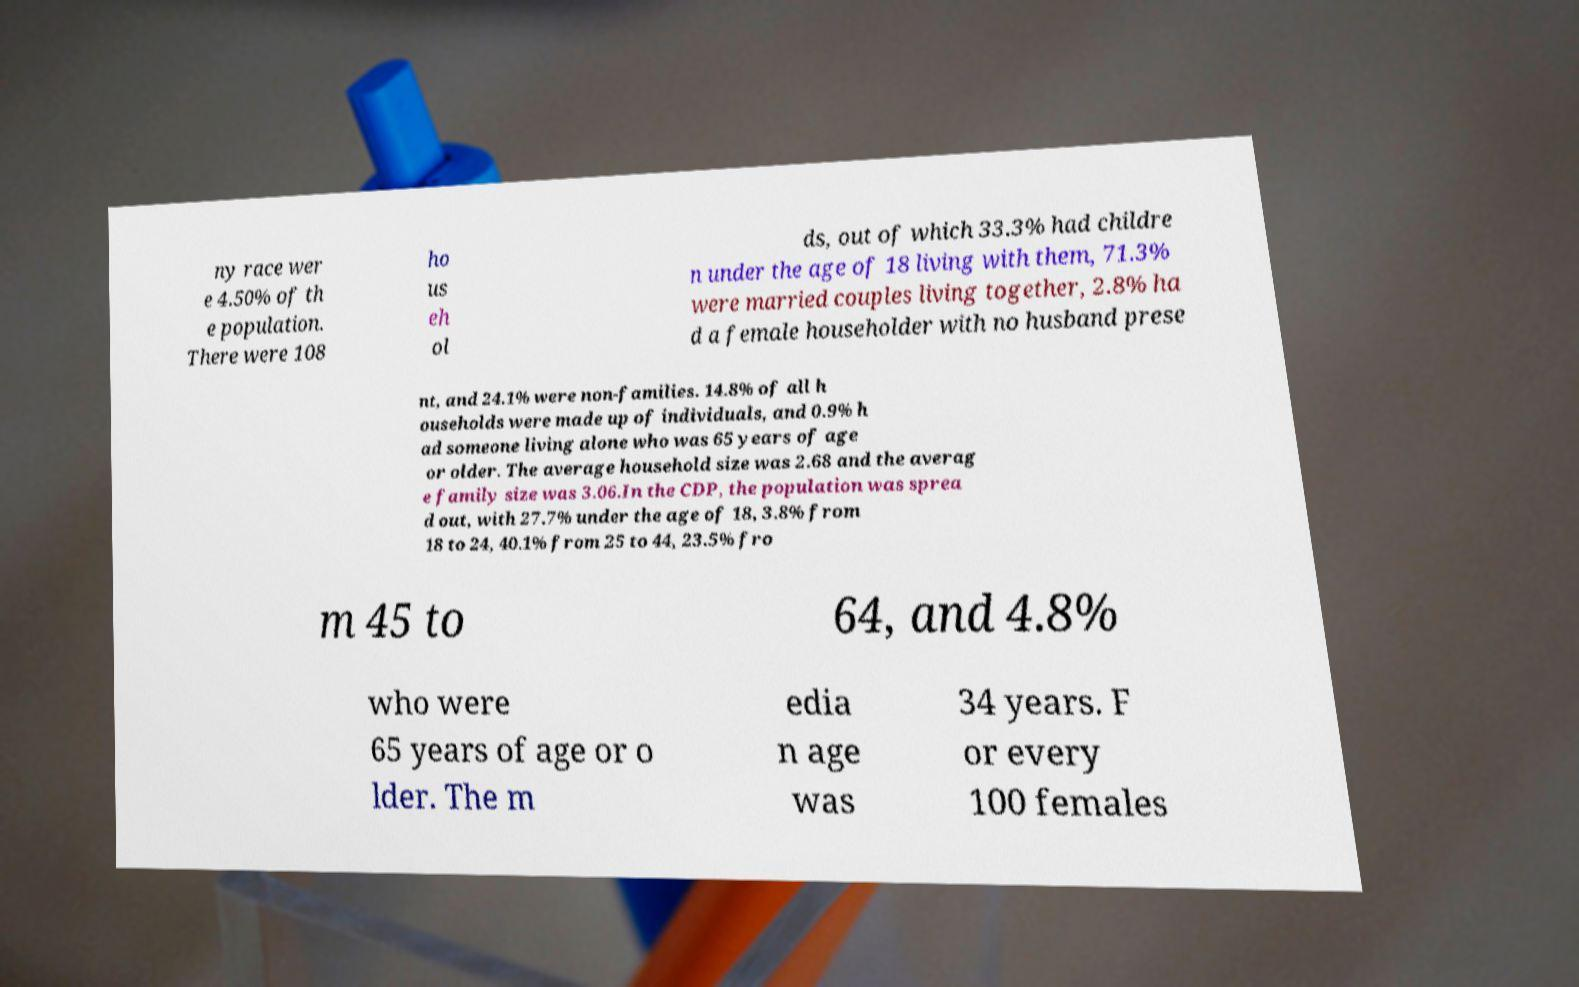Please read and relay the text visible in this image. What does it say? ny race wer e 4.50% of th e population. There were 108 ho us eh ol ds, out of which 33.3% had childre n under the age of 18 living with them, 71.3% were married couples living together, 2.8% ha d a female householder with no husband prese nt, and 24.1% were non-families. 14.8% of all h ouseholds were made up of individuals, and 0.9% h ad someone living alone who was 65 years of age or older. The average household size was 2.68 and the averag e family size was 3.06.In the CDP, the population was sprea d out, with 27.7% under the age of 18, 3.8% from 18 to 24, 40.1% from 25 to 44, 23.5% fro m 45 to 64, and 4.8% who were 65 years of age or o lder. The m edia n age was 34 years. F or every 100 females 